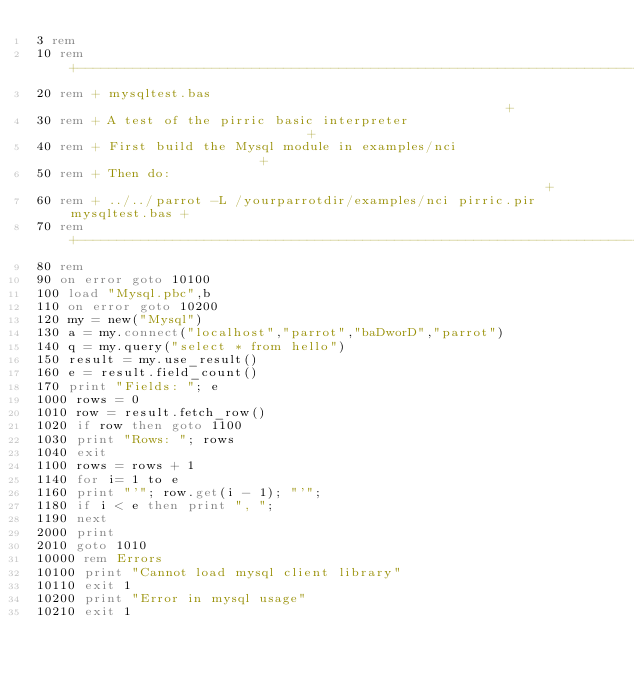Convert code to text. <code><loc_0><loc_0><loc_500><loc_500><_VisualBasic_>3 rem
10 rem +----------------------------------------------------------------------+
20 rem + mysqltest.bas                                                        +
30 rem + A test of the pirric basic interpreter                               +
40 rem + First build the Mysql module in examples/nci                         +
50 rem + Then do:                                                             +
60 rem + ../../parrot -L /yourparrotdir/examples/nci pirric.pir mysqltest.bas +
70 rem +----------------------------------------------------------------------+
80 rem
90 on error goto 10100
100 load "Mysql.pbc",b
110 on error goto 10200
120 my = new("Mysql")
130 a = my.connect("localhost","parrot","baDworD","parrot")
140 q = my.query("select * from hello")
150 result = my.use_result()
160 e = result.field_count()
170 print "Fields: "; e
1000 rows = 0
1010 row = result.fetch_row()
1020 if row then goto 1100
1030 print "Rows: "; rows
1040 exit
1100 rows = rows + 1
1140 for i= 1 to e
1160 print "'"; row.get(i - 1); "'";
1180 if i < e then print ", ";
1190 next
2000 print
2010 goto 1010
10000 rem Errors
10100 print "Cannot load mysql client library"
10110 exit 1
10200 print "Error in mysql usage"
10210 exit 1
</code> 